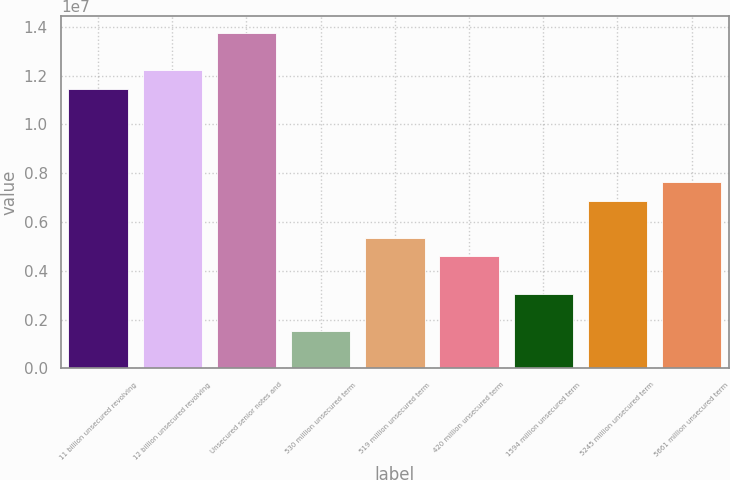Convert chart to OTSL. <chart><loc_0><loc_0><loc_500><loc_500><bar_chart><fcel>11 billion unsecured revolving<fcel>12 billion unsecured revolving<fcel>Unsecured senior notes and<fcel>530 million unsecured term<fcel>519 million unsecured term<fcel>420 million unsecured term<fcel>1594 million unsecured term<fcel>5245 million unsecured term<fcel>5661 million unsecured term<nl><fcel>1.1464e+07<fcel>1.2228e+07<fcel>1.37558e+07<fcel>1.5328e+06<fcel>5.3525e+06<fcel>4.58856e+06<fcel>3.06068e+06<fcel>6.88038e+06<fcel>7.64432e+06<nl></chart> 